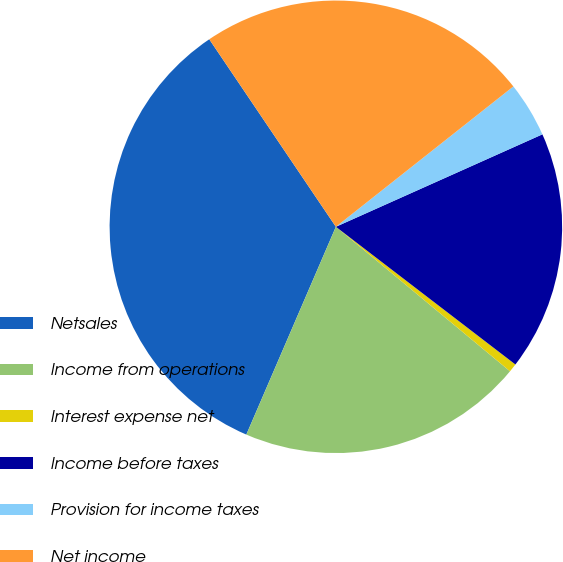Convert chart. <chart><loc_0><loc_0><loc_500><loc_500><pie_chart><fcel>Netsales<fcel>Income from operations<fcel>Interest expense net<fcel>Income before taxes<fcel>Provision for income taxes<fcel>Net income<nl><fcel>34.07%<fcel>20.45%<fcel>0.61%<fcel>17.11%<fcel>3.95%<fcel>23.8%<nl></chart> 